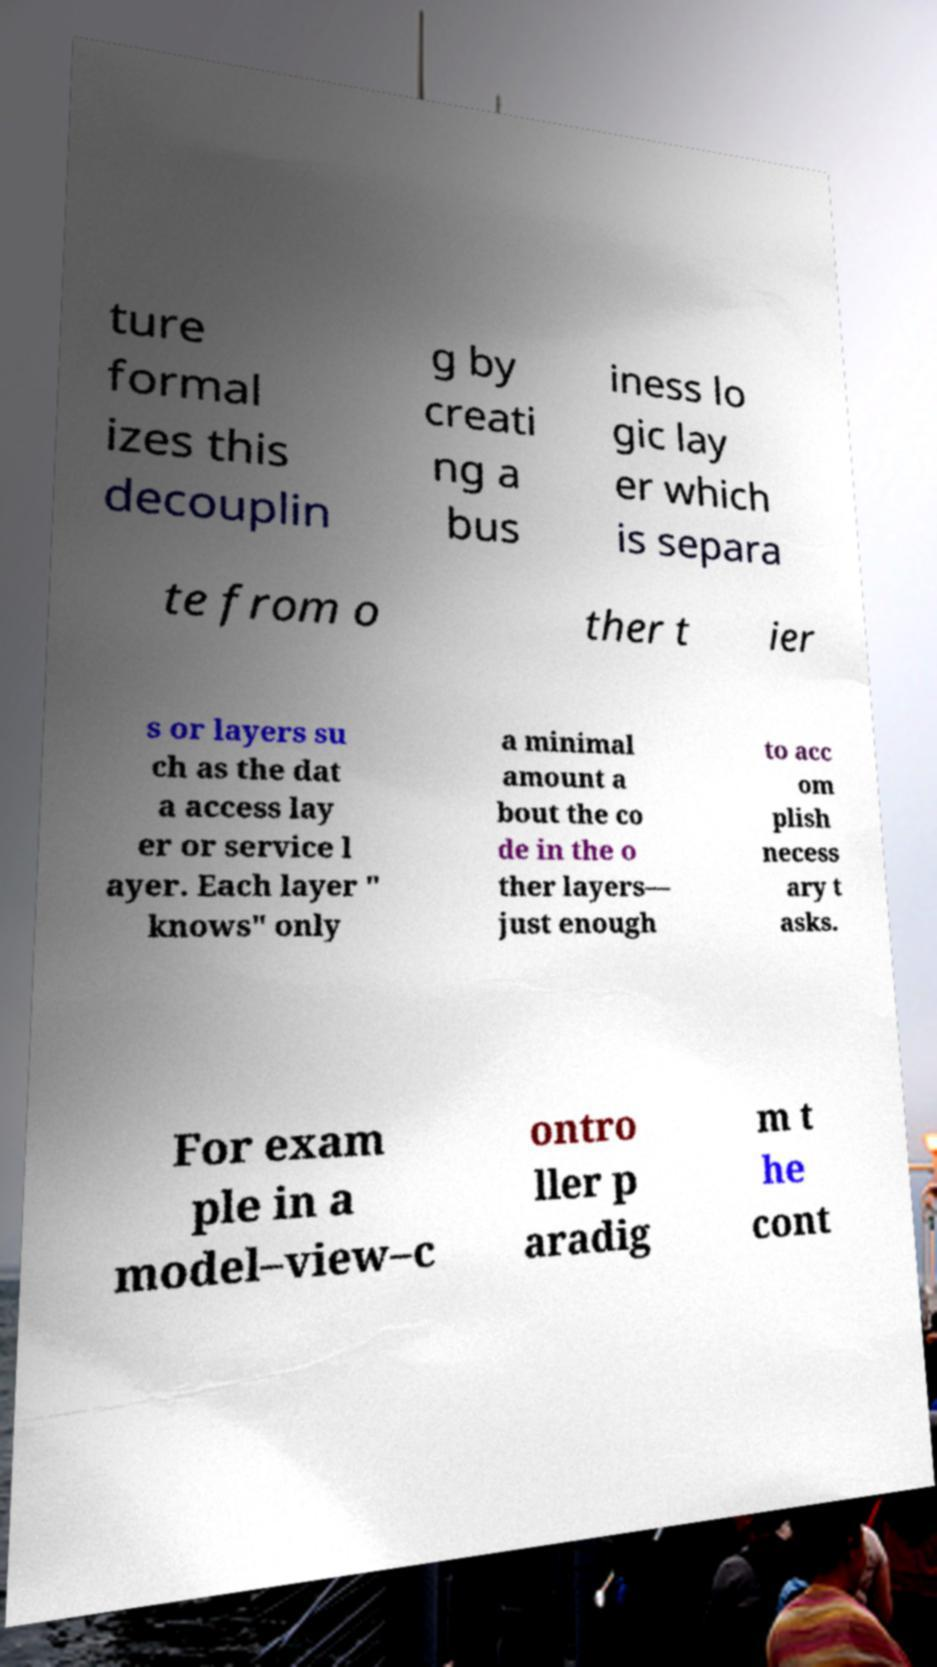What messages or text are displayed in this image? I need them in a readable, typed format. ture formal izes this decouplin g by creati ng a bus iness lo gic lay er which is separa te from o ther t ier s or layers su ch as the dat a access lay er or service l ayer. Each layer " knows" only a minimal amount a bout the co de in the o ther layers— just enough to acc om plish necess ary t asks. For exam ple in a model–view–c ontro ller p aradig m t he cont 